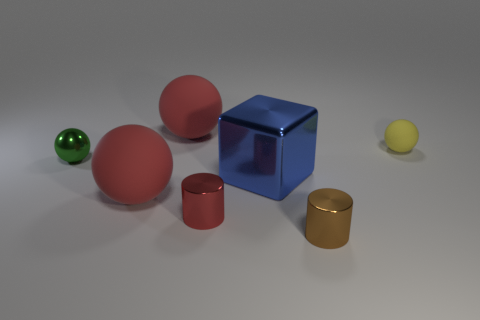What number of blue metal cubes are there?
Ensure brevity in your answer.  1. Is the large metal block the same color as the small matte sphere?
Make the answer very short. No. The rubber thing that is behind the green metal ball and to the left of the yellow thing is what color?
Provide a short and direct response. Red. There is a red shiny cylinder; are there any blue shiny cubes on the left side of it?
Your answer should be very brief. No. What number of brown shiny cylinders are in front of the rubber thing right of the red cylinder?
Keep it short and to the point. 1. The blue cube that is made of the same material as the green object is what size?
Make the answer very short. Large. The metal cube is what size?
Ensure brevity in your answer.  Large. Is the small yellow object made of the same material as the large block?
Provide a succinct answer. No. What number of cubes are either brown shiny objects or small yellow matte things?
Ensure brevity in your answer.  0. There is a cylinder that is right of the red cylinder behind the brown metallic thing; what color is it?
Make the answer very short. Brown. 